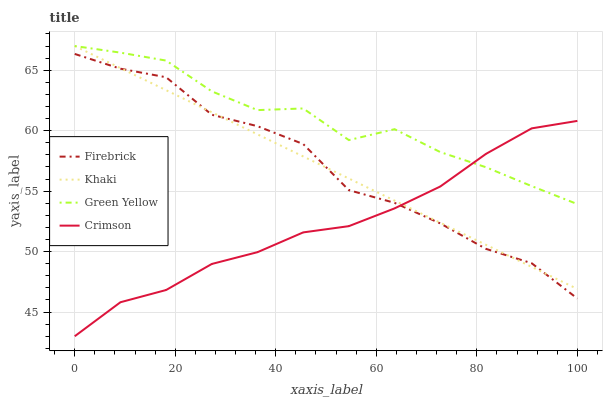Does Crimson have the minimum area under the curve?
Answer yes or no. Yes. Does Green Yellow have the maximum area under the curve?
Answer yes or no. Yes. Does Firebrick have the minimum area under the curve?
Answer yes or no. No. Does Firebrick have the maximum area under the curve?
Answer yes or no. No. Is Khaki the smoothest?
Answer yes or no. Yes. Is Green Yellow the roughest?
Answer yes or no. Yes. Is Firebrick the smoothest?
Answer yes or no. No. Is Firebrick the roughest?
Answer yes or no. No. Does Crimson have the lowest value?
Answer yes or no. Yes. Does Firebrick have the lowest value?
Answer yes or no. No. Does Green Yellow have the highest value?
Answer yes or no. Yes. Does Firebrick have the highest value?
Answer yes or no. No. Is Firebrick less than Green Yellow?
Answer yes or no. Yes. Is Green Yellow greater than Firebrick?
Answer yes or no. Yes. Does Crimson intersect Firebrick?
Answer yes or no. Yes. Is Crimson less than Firebrick?
Answer yes or no. No. Is Crimson greater than Firebrick?
Answer yes or no. No. Does Firebrick intersect Green Yellow?
Answer yes or no. No. 